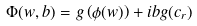Convert formula to latex. <formula><loc_0><loc_0><loc_500><loc_500>\Phi ( w , b ) = g \left ( \phi ( w ) \right ) + i b g ( c _ { r } )</formula> 